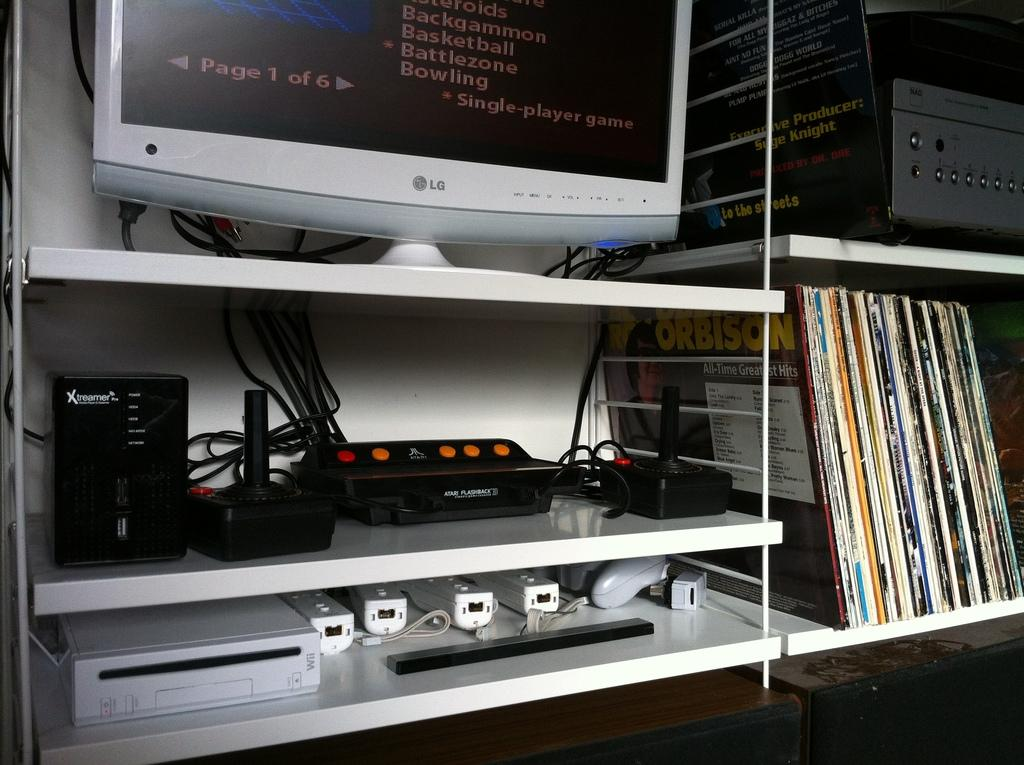<image>
Provide a brief description of the given image. A Wii console on a shelf below an LG monitor. 